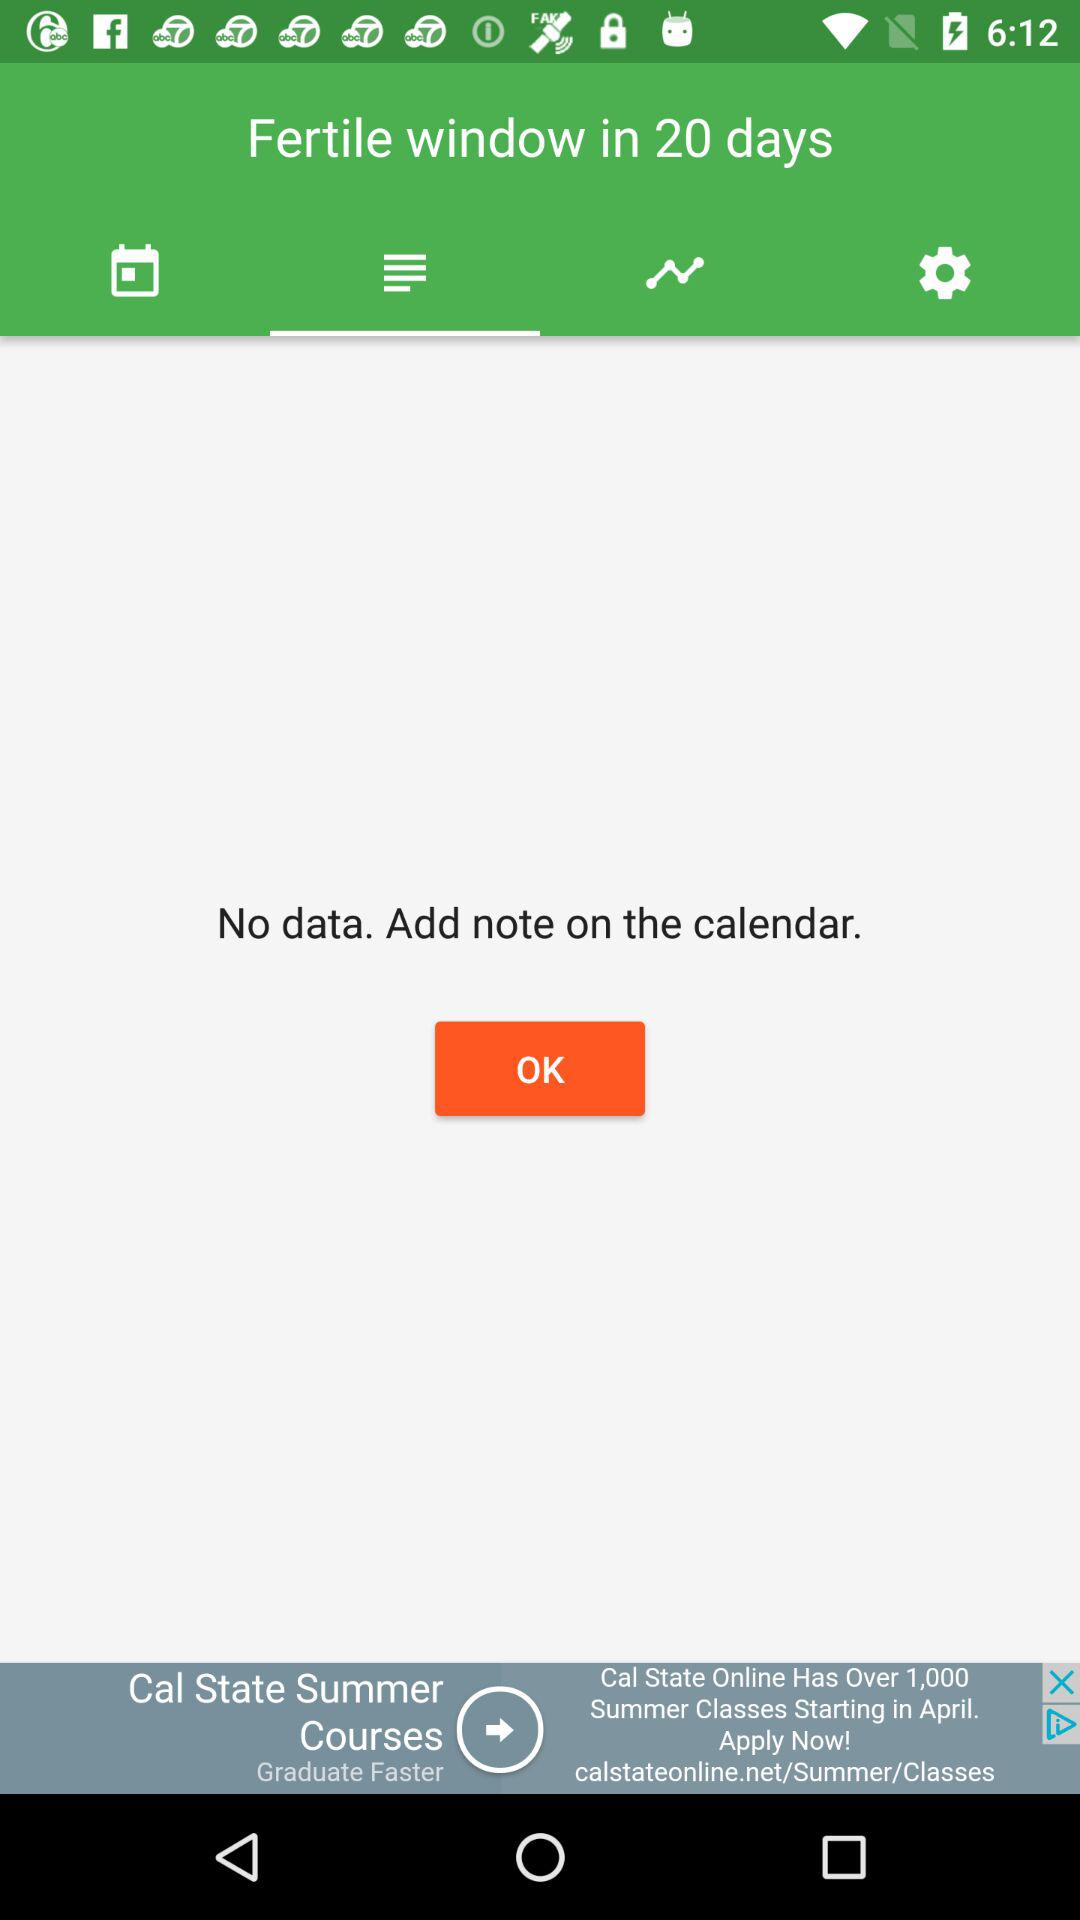Where to add a note? Add a note to the calendar. 